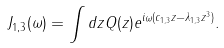Convert formula to latex. <formula><loc_0><loc_0><loc_500><loc_500>J _ { 1 , 3 } ( \omega ) = \int d z Q ( z ) e ^ { i \omega ( c _ { 1 , 3 } z - \lambda _ { 1 , 3 } z ^ { 3 } ) } .</formula> 